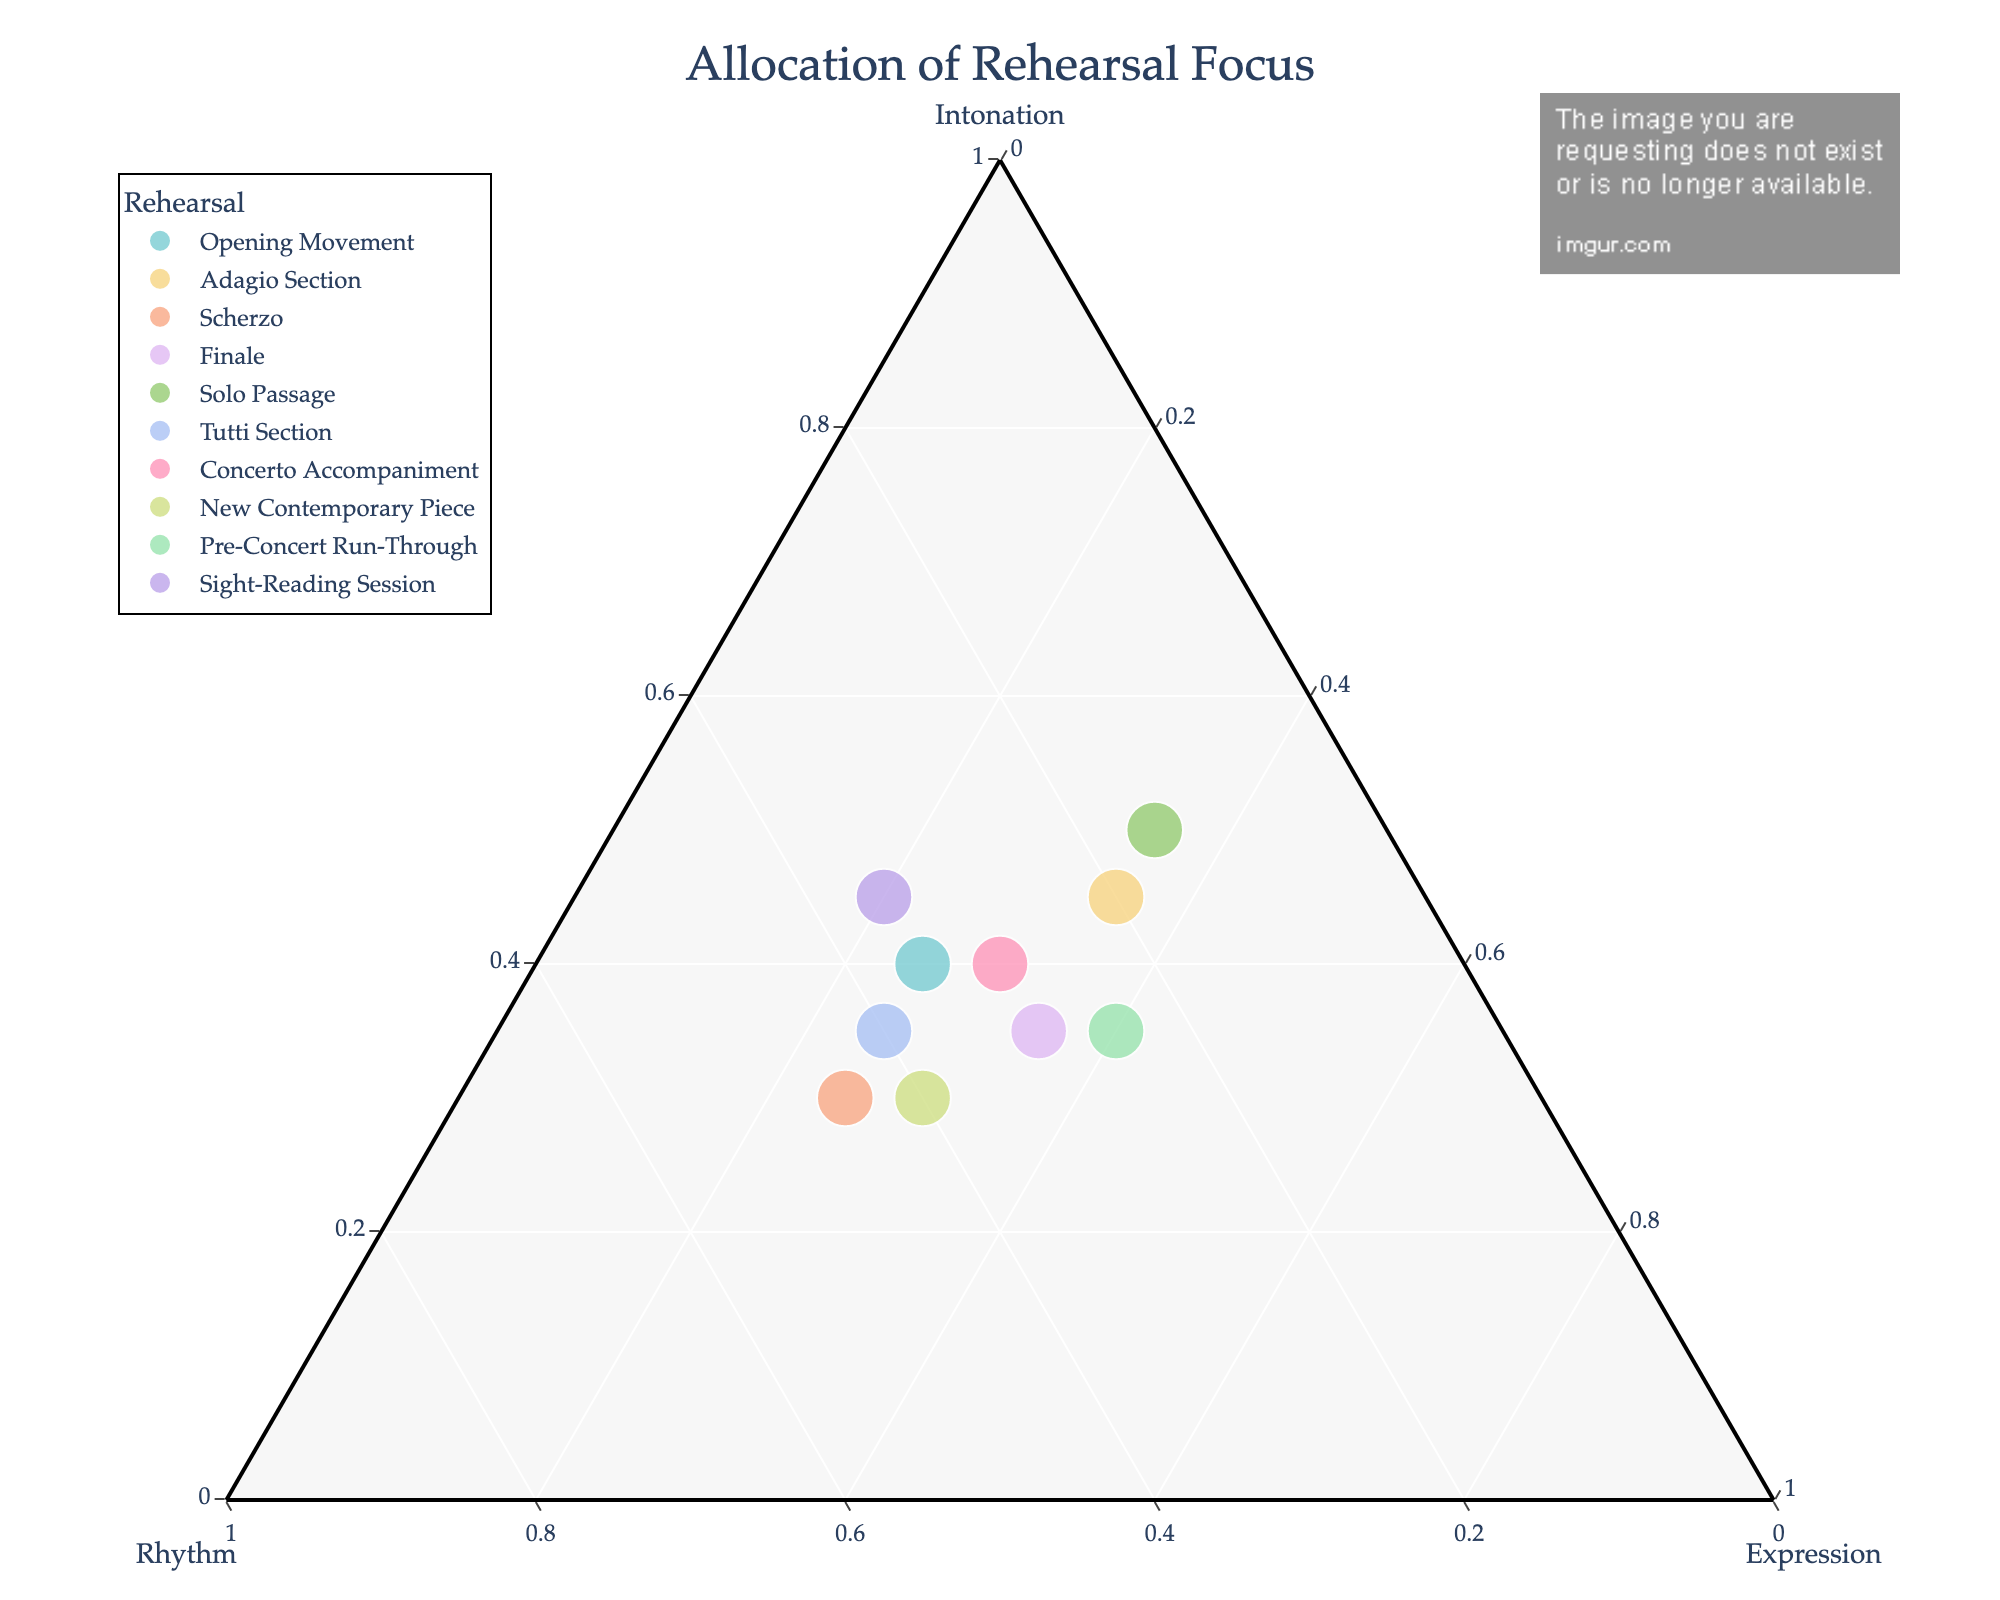What is the title of the plot? The title is typically shown prominently at the top of the plot. It summarizes the main focus of the visual representation.
Answer: Allocation of Rehearsal Focus How many rehearsal types are included in the plot? Look for the number of unique data points or labels representing different rehearsal types.
Answer: 10 Which rehearsal type has the highest focus on intonation? Identify the point in the plot that is closest to the intonation vertex. This represents the highest allocation of rehearsal focus on intonation.
Answer: Solo Passage Is there any rehearsal type where the focus on rhythm is greater than both intonation and expression? Check the data points to see if any of them lie closer to the rhythm vertex than the other two.
Answer: Scherzo How does the focus on expression for the Adagio Section compare to the Finale? Compare the positions of these two points along the expression axis to see which one is closer to the expression vertex.
Answer: Adagio Section has the same focus on expression as Finale Which rehearsal type has the most balanced focus across intonation, rhythm, and expression? Look for a point that is roughly equidistant from all three vertices, indicating a balanced allocation.
Answer: Concerto Accompaniment What is the total allocation of focus for the Opening Movement? First, find the point that represents the Opening Movement. Check its coordinates to sum up the normalized values.
Answer: 1 In which rehearsal type is the focus on rhythm the lowest? Identify the data point that is positioned the farthest from the rhythm vertex, indicating the lowest focus on rhythm.
Answer: Solo Passage Which rehearsal type shows the biggest contrast between intonation and expression focus? Find the data point where the difference between intonation and expression values is the greatest.
Answer: Sight-Reading Session 